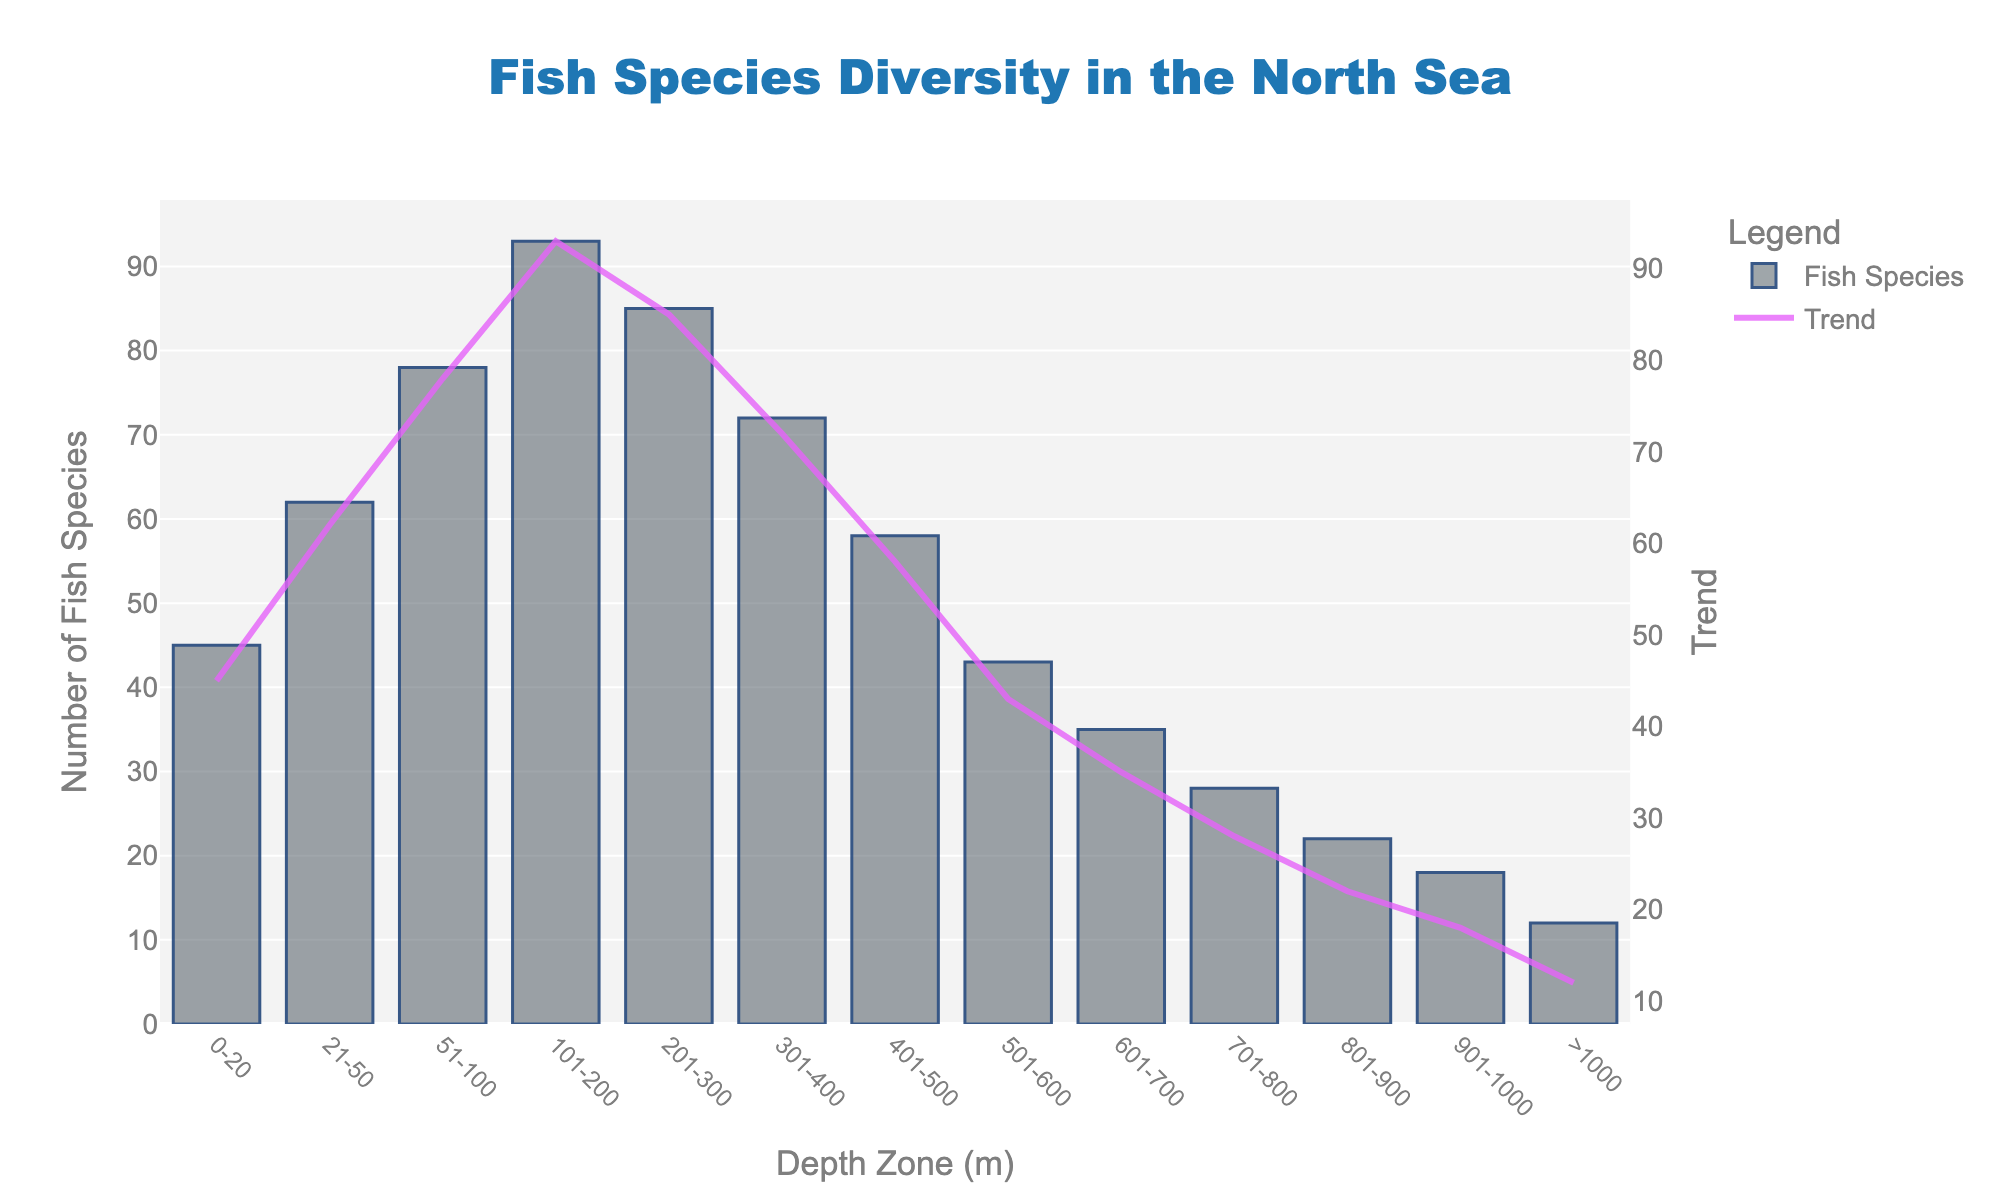What is the depth zone with the highest number of fish species? The depth zone with the highest number of fish species can be identified by finding the bar with the maximum height. This occurs at '101-200' meters depth zone.
Answer: 101-200 meters Which depth zone has the least number of fish species? To find this, look for the shortest bar in the chart. The 'greater than 1000' meters zone has the shortest bar.
Answer: Greater than 1000 meters What is the difference in the number of fish species between the 101-200 meters zone and the 0-20 meters zone? The number of fish species in the 101-200 meters zone is 93, and in the 0-20 meters zone is 45. Subtract 45 from 93 to find the difference.
Answer: 48 How does the fish species diversity trend change from 101-200 meters to greater than 1000 meters? Observe the line trace in the chart for the trend. It shows a decline in the number of fish species from 101-200 meters to greater than 1000 meters.
Answer: Declines Which depth zone ranges from 21-50 meters? Identify the bar labeled '21-50' meters range. This depth zone has the second bar from the left on the x-axis.
Answer: 21-50 meters Is there an increase or decrease in species diversity between 201-300 meters and 401-500 meters? Compare the heights of the bars for '201-300' meters and '401-500' meters. The 201-300 meters bar is taller than the 401-500 meters bar, indicating a decrease in diversity.
Answer: Decrease What is the total number of fish species for depths ranging from 0 to 100 meters? Sum the number of fish species for the zones 0-20 meters, 21-50 meters, and 51-100 meters: 45 + 62 + 78 = 185.
Answer: 185 How does the species diversity compare between 301-400 meters and 801-900 meters? Compare the heights of the bars for these depth zones. The 301-400 meters bar is taller than the 801-900 meters bar.
Answer: Higher at 301-400 meters What is the average number of fish species across all depth zones? Calculate the average by summing all the numbers and dividing by the total number of zones. Sum is 651, the number of zones is 13, so 651 / 13 = 50.08.
Answer: 50.08 If we combine the species count of the two deepest zones (>1000 meters and 901-1000 meters), what is the resulting number? Add the number of fish species for these zones: 12 + 18 = 30.
Answer: 30 